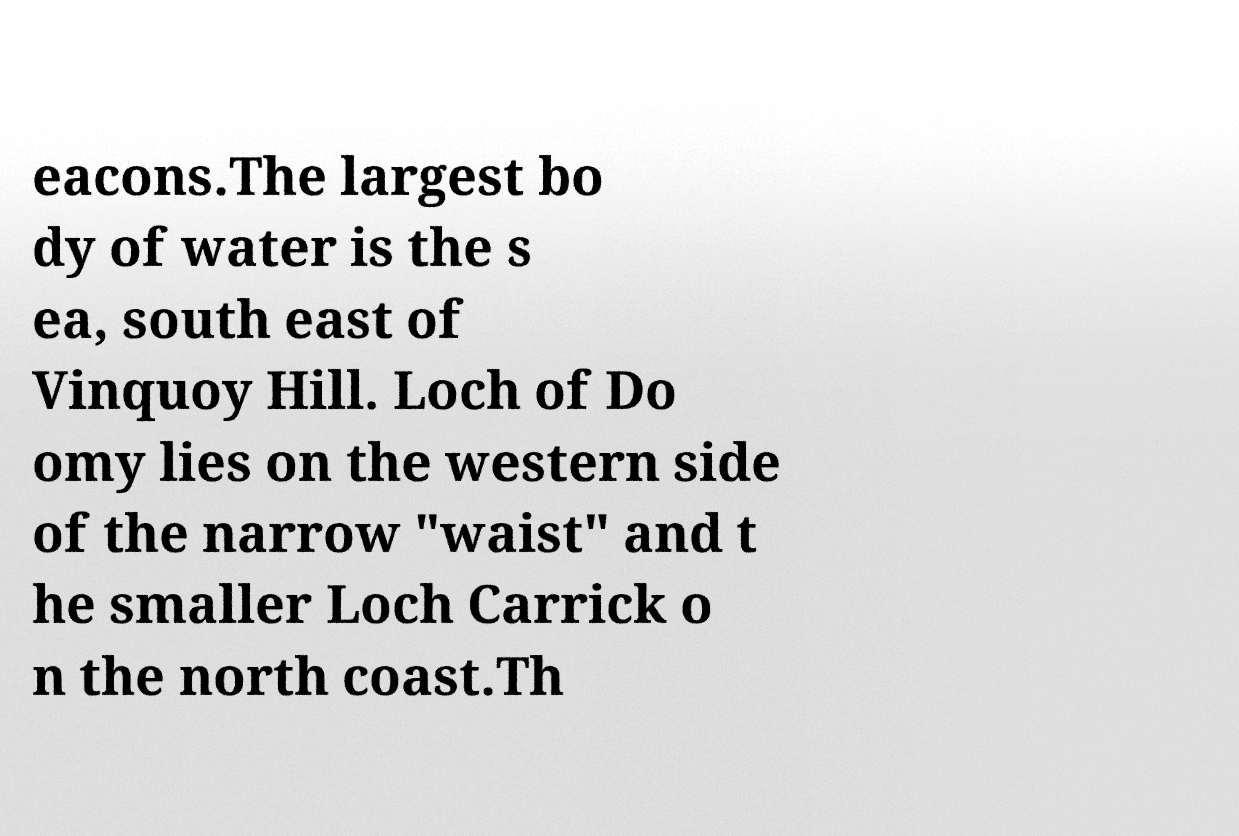Can you accurately transcribe the text from the provided image for me? eacons.The largest bo dy of water is the s ea, south east of Vinquoy Hill. Loch of Do omy lies on the western side of the narrow "waist" and t he smaller Loch Carrick o n the north coast.Th 